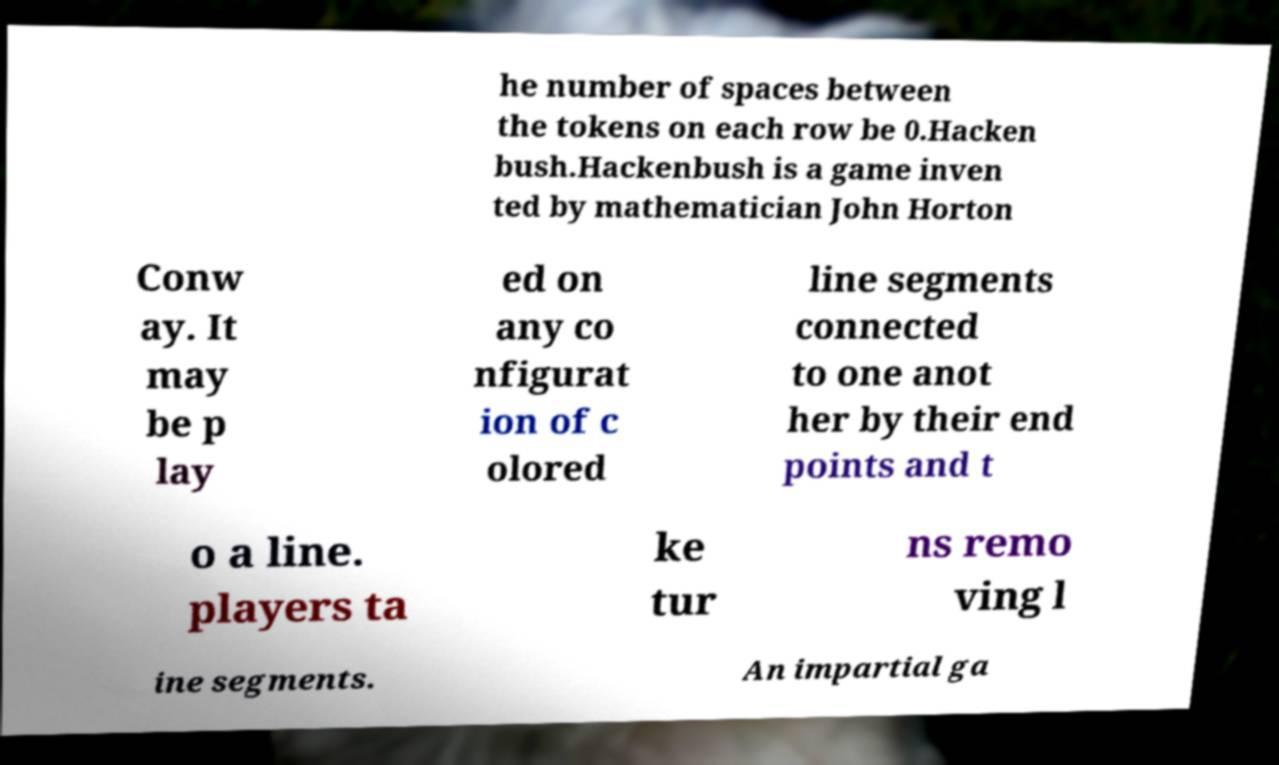For documentation purposes, I need the text within this image transcribed. Could you provide that? he number of spaces between the tokens on each row be 0.Hacken bush.Hackenbush is a game inven ted by mathematician John Horton Conw ay. It may be p lay ed on any co nfigurat ion of c olored line segments connected to one anot her by their end points and t o a line. players ta ke tur ns remo ving l ine segments. An impartial ga 